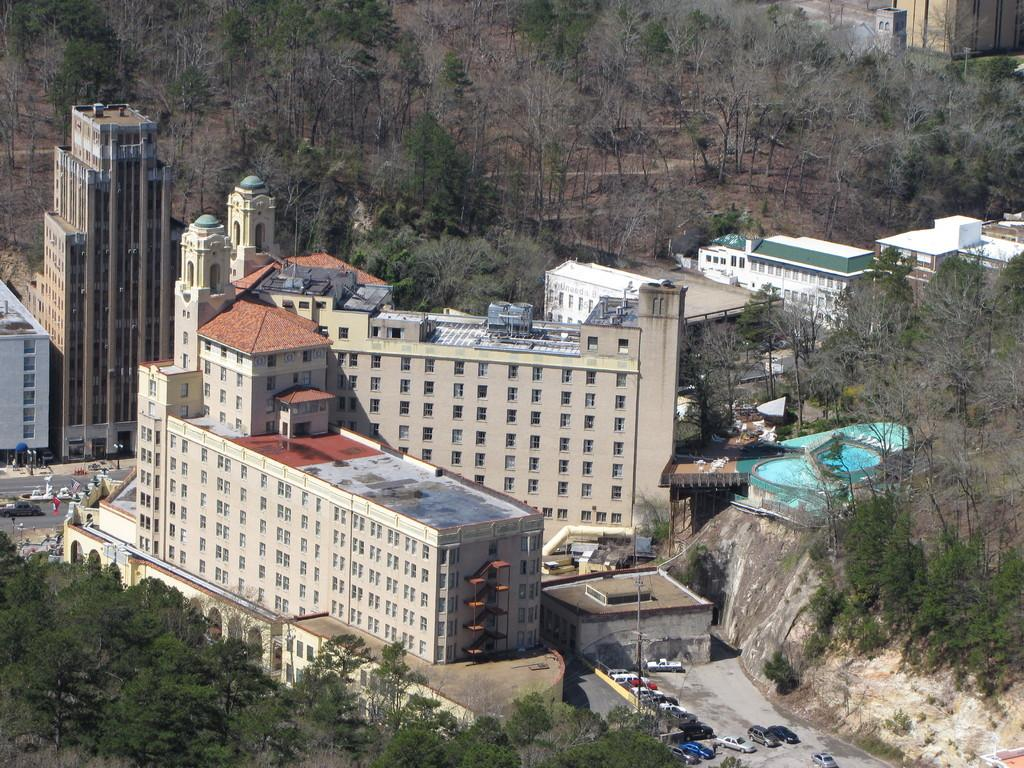What type of natural elements can be seen in the middle of the image? There are trees in the middle of the image. What type of man-made structures are present in the middle of the image? There are buildings in the middle of the image. What type of transportation is visible in the middle of the image? There are vehicles in the middle of the image. What type of vertical structures can be seen in the middle of the image? There are poles in the middle of the image. What type of religious symbol can be seen in the middle of the image? There is no religious symbol present in the image; the facts provided only mention trees, buildings, vehicles, and poles. How does the sock move around in the image? There is no sock present in the image, so it cannot be moving around. 